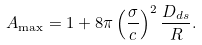Convert formula to latex. <formula><loc_0><loc_0><loc_500><loc_500>A _ { \max } = 1 + 8 \pi \left ( \frac { \sigma } { c } \right ) ^ { 2 } \frac { D _ { d s } } { R } .</formula> 